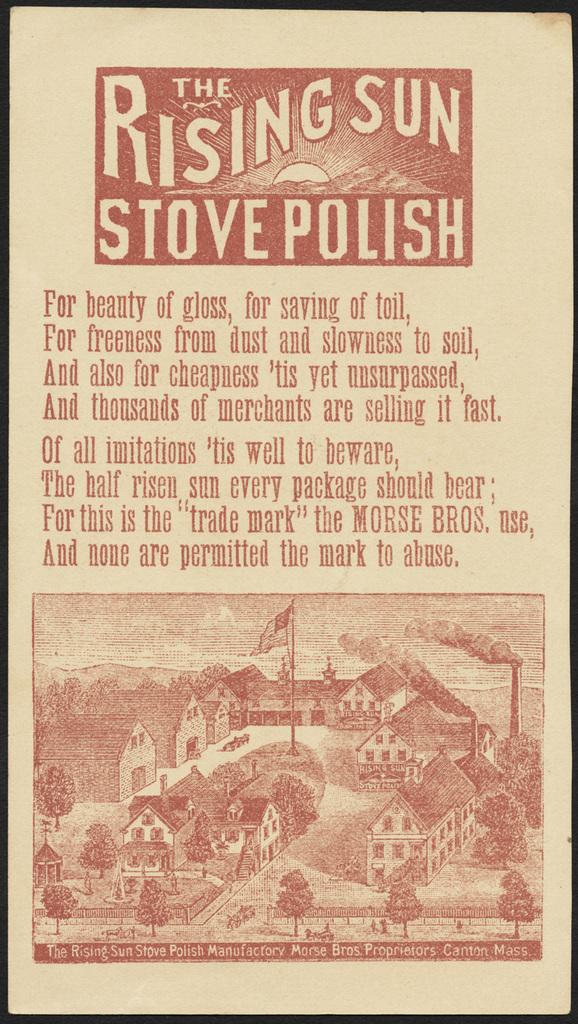<image>
Create a compact narrative representing the image presented. A label for the rising sun stove polish. 